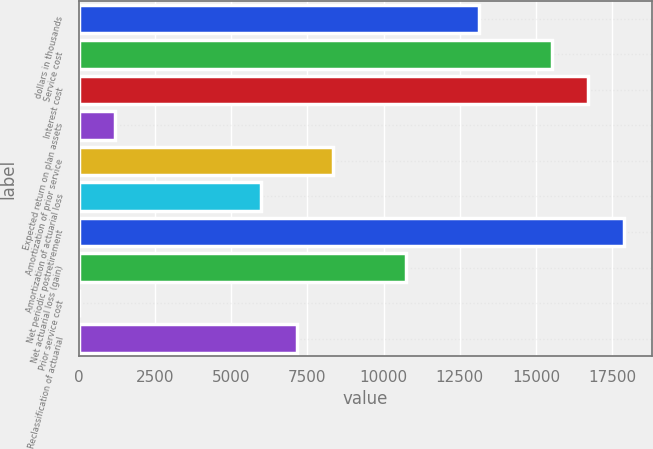<chart> <loc_0><loc_0><loc_500><loc_500><bar_chart><fcel>dollars in thousands<fcel>Service cost<fcel>Interest cost<fcel>Expected return on plan assets<fcel>Amortization of prior service<fcel>Amortization of actuarial loss<fcel>Net periodic postretirement<fcel>Net actuarial loss (gain)<fcel>Prior service cost<fcel>Reclassification of actuarial<nl><fcel>13123.9<fcel>15509.8<fcel>16702.7<fcel>1194.6<fcel>8352.18<fcel>5966.32<fcel>17895.6<fcel>10738<fcel>1.67<fcel>7159.25<nl></chart> 